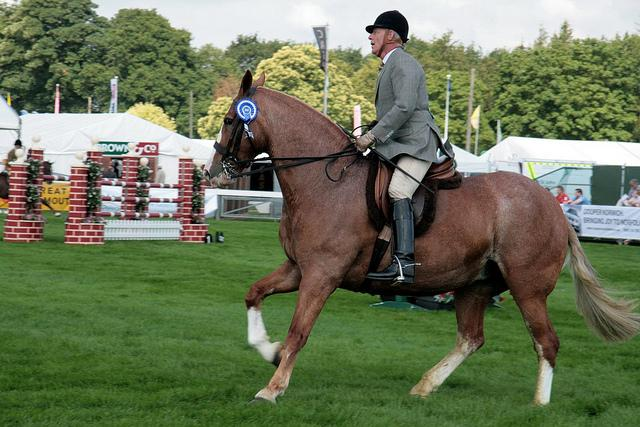What does the man have on? boots 